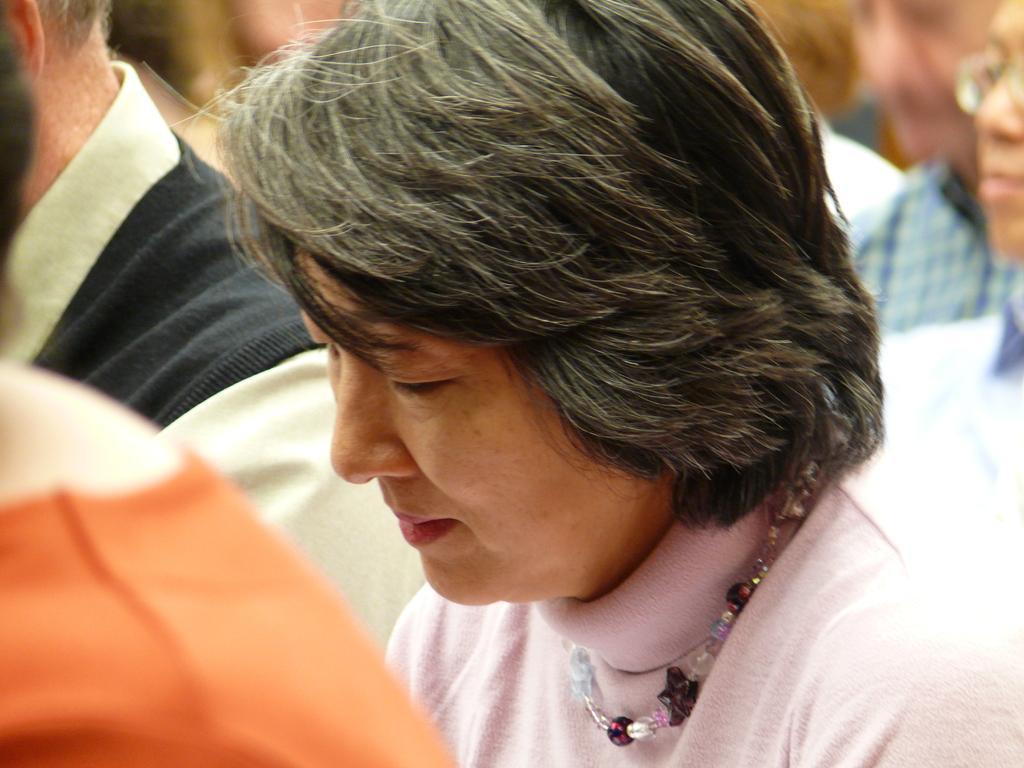Could you give a brief overview of what you see in this image? In this picture, we see the woman is wearing the pink T-shirt. She is wearing a bead chain. In front of her, we see a person is wearing an orange T-shirt. Beside him, we see a man in the black jacket. Behind her, we see the people. This picture is blurred in the background. 